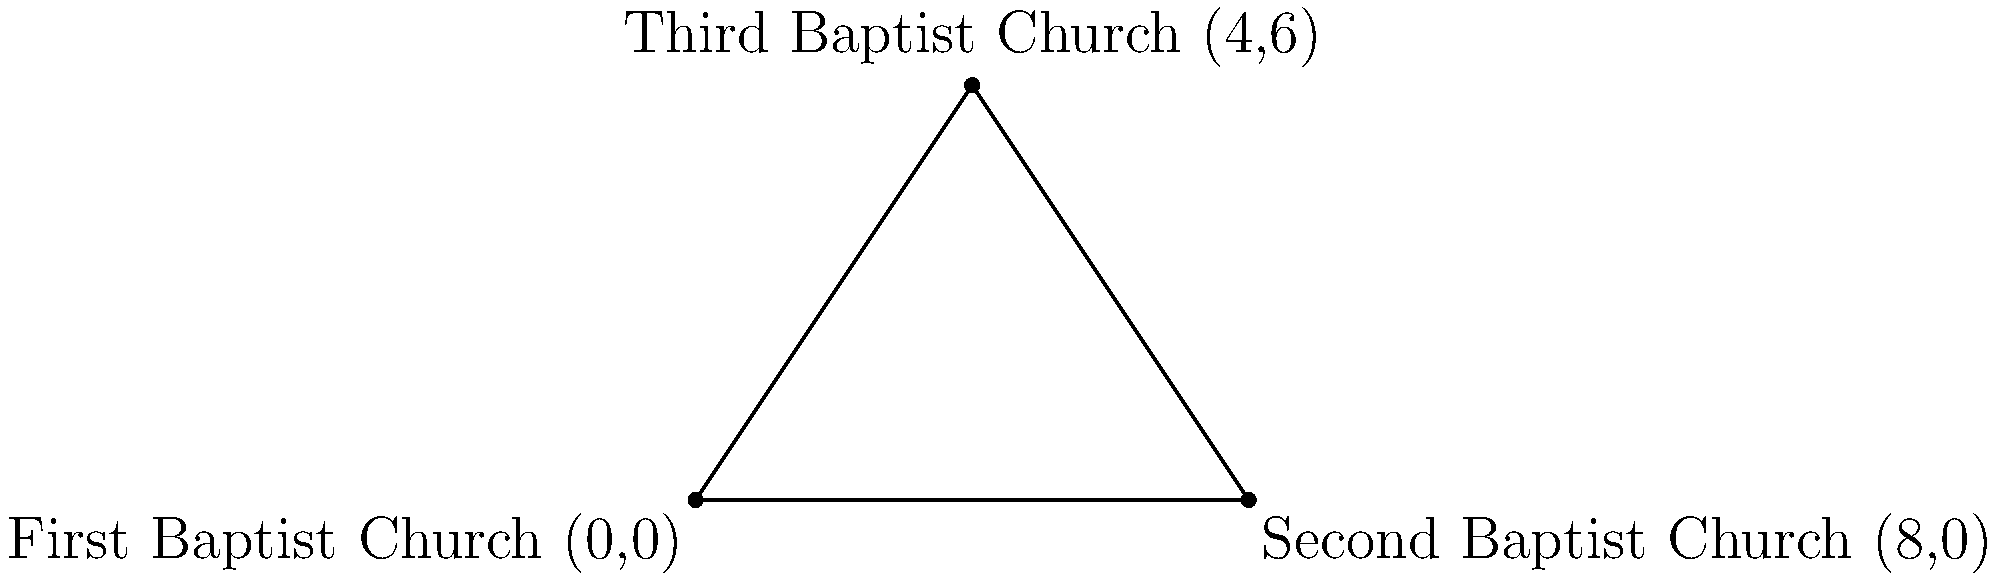Three Baptist churches in a town are represented by points on a coordinate plane. The First Baptist Church is located at (0,0), the Second Baptist Church at (8,0), and the Third Baptist Church at (4,6). Calculate the area of the triangle formed by connecting these three churches on the map. To find the area of the triangle, we can use the formula:

Area = $\frac{1}{2}|x_1(y_2 - y_3) + x_2(y_3 - y_1) + x_3(y_1 - y_2)|$

Where $(x_1, y_1)$, $(x_2, y_2)$, and $(x_3, y_3)$ are the coordinates of the three points.

Let's assign our points:
First Baptist Church: $(x_1, y_1) = (0, 0)$
Second Baptist Church: $(x_2, y_2) = (8, 0)$
Third Baptist Church: $(x_3, y_3) = (4, 6)$

Now, let's substitute these into our formula:

Area = $\frac{1}{2}|0(0 - 6) + 8(6 - 0) + 4(0 - 0)|$

Simplifying:
Area = $\frac{1}{2}|0 + 48 + 0|$
Area = $\frac{1}{2}(48)$
Area = $24$

Therefore, the area of the triangle formed by the three Baptist churches is 24 square units.
Answer: 24 square units 